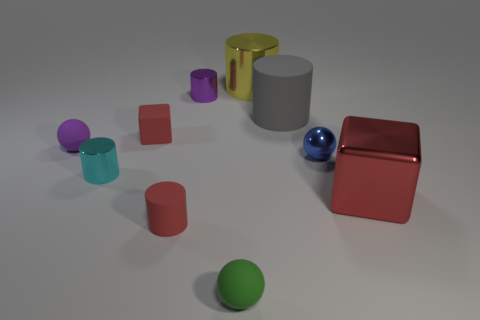The red object that is on the left side of the blue thing and in front of the cyan object is made of what material?
Provide a short and direct response. Rubber. How many large objects are purple shiny things or blue balls?
Your answer should be very brief. 0. What is the size of the purple ball?
Offer a very short reply. Small. What is the shape of the large yellow shiny object?
Provide a short and direct response. Cylinder. Is there anything else that is the same shape as the large yellow object?
Keep it short and to the point. Yes. Are there fewer tiny red cylinders that are on the left side of the green ball than tiny cyan cylinders?
Your answer should be compact. No. Is the color of the metallic thing right of the shiny ball the same as the tiny rubber cylinder?
Make the answer very short. Yes. How many matte things are small red things or large gray things?
Provide a short and direct response. 3. Is there anything else that has the same size as the green matte sphere?
Offer a terse response. Yes. The block that is the same material as the small purple sphere is what color?
Provide a succinct answer. Red. 